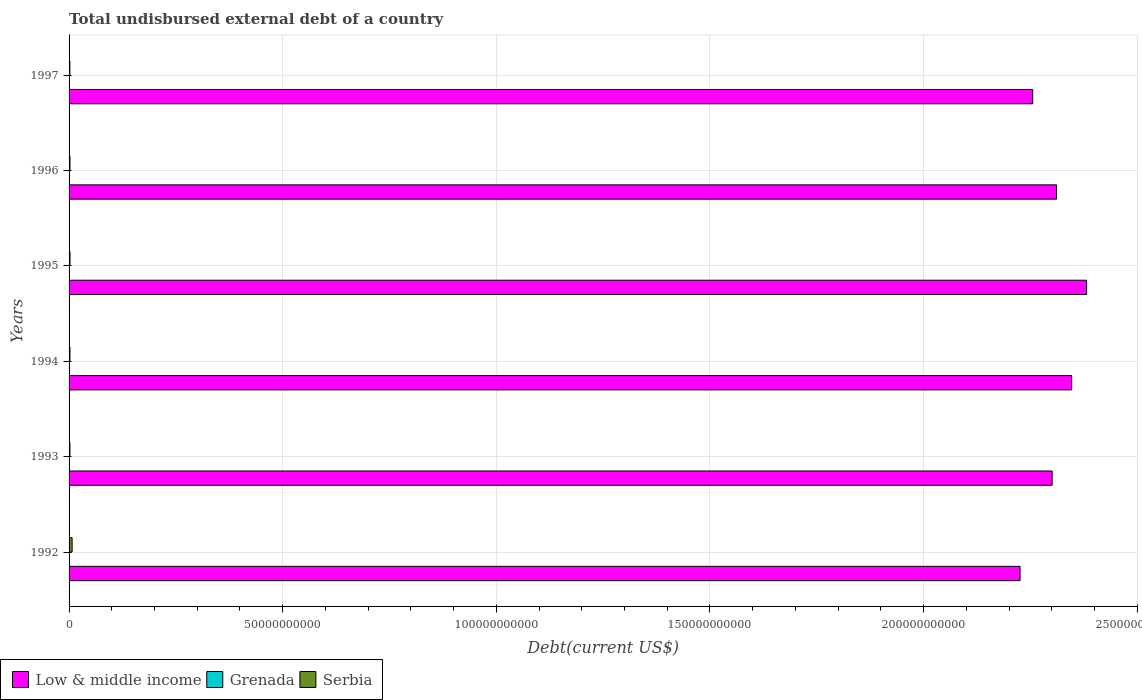Are the number of bars per tick equal to the number of legend labels?
Ensure brevity in your answer.  Yes. Are the number of bars on each tick of the Y-axis equal?
Your answer should be very brief. Yes. What is the label of the 2nd group of bars from the top?
Keep it short and to the point. 1996. What is the total undisbursed external debt in Serbia in 1993?
Ensure brevity in your answer.  2.00e+08. Across all years, what is the maximum total undisbursed external debt in Serbia?
Provide a succinct answer. 7.14e+08. Across all years, what is the minimum total undisbursed external debt in Low & middle income?
Give a very brief answer. 2.23e+11. In which year was the total undisbursed external debt in Serbia maximum?
Offer a terse response. 1992. What is the total total undisbursed external debt in Low & middle income in the graph?
Give a very brief answer. 1.38e+12. What is the difference between the total undisbursed external debt in Low & middle income in 1992 and that in 1996?
Offer a terse response. -8.54e+09. What is the difference between the total undisbursed external debt in Low & middle income in 1994 and the total undisbursed external debt in Serbia in 1995?
Your answer should be very brief. 2.34e+11. What is the average total undisbursed external debt in Serbia per year?
Keep it short and to the point. 2.91e+08. In the year 1992, what is the difference between the total undisbursed external debt in Low & middle income and total undisbursed external debt in Serbia?
Your response must be concise. 2.22e+11. What is the ratio of the total undisbursed external debt in Serbia in 1992 to that in 1996?
Your answer should be compact. 3.37. Is the difference between the total undisbursed external debt in Low & middle income in 1994 and 1996 greater than the difference between the total undisbursed external debt in Serbia in 1994 and 1996?
Offer a terse response. Yes. What is the difference between the highest and the second highest total undisbursed external debt in Low & middle income?
Your response must be concise. 3.49e+09. What is the difference between the highest and the lowest total undisbursed external debt in Grenada?
Keep it short and to the point. 1.32e+07. Is the sum of the total undisbursed external debt in Low & middle income in 1993 and 1995 greater than the maximum total undisbursed external debt in Serbia across all years?
Make the answer very short. Yes. What does the 2nd bar from the top in 1997 represents?
Make the answer very short. Grenada. How many bars are there?
Ensure brevity in your answer.  18. How many years are there in the graph?
Provide a succinct answer. 6. What is the difference between two consecutive major ticks on the X-axis?
Your response must be concise. 5.00e+1. Does the graph contain grids?
Provide a succinct answer. Yes. Where does the legend appear in the graph?
Provide a short and direct response. Bottom left. How many legend labels are there?
Your answer should be compact. 3. How are the legend labels stacked?
Your answer should be very brief. Horizontal. What is the title of the graph?
Provide a short and direct response. Total undisbursed external debt of a country. Does "Moldova" appear as one of the legend labels in the graph?
Provide a short and direct response. No. What is the label or title of the X-axis?
Provide a short and direct response. Debt(current US$). What is the Debt(current US$) of Low & middle income in 1992?
Provide a succinct answer. 2.23e+11. What is the Debt(current US$) in Grenada in 1992?
Your answer should be compact. 2.28e+07. What is the Debt(current US$) in Serbia in 1992?
Give a very brief answer. 7.14e+08. What is the Debt(current US$) of Low & middle income in 1993?
Offer a terse response. 2.30e+11. What is the Debt(current US$) of Grenada in 1993?
Make the answer very short. 1.79e+07. What is the Debt(current US$) of Serbia in 1993?
Offer a very short reply. 2.00e+08. What is the Debt(current US$) of Low & middle income in 1994?
Make the answer very short. 2.35e+11. What is the Debt(current US$) in Grenada in 1994?
Offer a very short reply. 1.91e+07. What is the Debt(current US$) in Serbia in 1994?
Give a very brief answer. 2.08e+08. What is the Debt(current US$) of Low & middle income in 1995?
Your response must be concise. 2.38e+11. What is the Debt(current US$) of Grenada in 1995?
Give a very brief answer. 3.11e+07. What is the Debt(current US$) of Serbia in 1995?
Ensure brevity in your answer.  2.22e+08. What is the Debt(current US$) in Low & middle income in 1996?
Offer a very short reply. 2.31e+11. What is the Debt(current US$) in Grenada in 1996?
Your answer should be compact. 2.90e+07. What is the Debt(current US$) in Serbia in 1996?
Keep it short and to the point. 2.12e+08. What is the Debt(current US$) in Low & middle income in 1997?
Ensure brevity in your answer.  2.26e+11. What is the Debt(current US$) in Grenada in 1997?
Provide a short and direct response. 2.65e+07. What is the Debt(current US$) in Serbia in 1997?
Offer a terse response. 1.87e+08. Across all years, what is the maximum Debt(current US$) in Low & middle income?
Your answer should be compact. 2.38e+11. Across all years, what is the maximum Debt(current US$) of Grenada?
Your answer should be compact. 3.11e+07. Across all years, what is the maximum Debt(current US$) of Serbia?
Provide a short and direct response. 7.14e+08. Across all years, what is the minimum Debt(current US$) of Low & middle income?
Keep it short and to the point. 2.23e+11. Across all years, what is the minimum Debt(current US$) of Grenada?
Provide a short and direct response. 1.79e+07. Across all years, what is the minimum Debt(current US$) in Serbia?
Provide a short and direct response. 1.87e+08. What is the total Debt(current US$) of Low & middle income in the graph?
Provide a succinct answer. 1.38e+12. What is the total Debt(current US$) in Grenada in the graph?
Provide a short and direct response. 1.46e+08. What is the total Debt(current US$) in Serbia in the graph?
Your response must be concise. 1.74e+09. What is the difference between the Debt(current US$) of Low & middle income in 1992 and that in 1993?
Ensure brevity in your answer.  -7.50e+09. What is the difference between the Debt(current US$) in Grenada in 1992 and that in 1993?
Make the answer very short. 4.84e+06. What is the difference between the Debt(current US$) of Serbia in 1992 and that in 1993?
Your response must be concise. 5.14e+08. What is the difference between the Debt(current US$) of Low & middle income in 1992 and that in 1994?
Your response must be concise. -1.21e+1. What is the difference between the Debt(current US$) of Grenada in 1992 and that in 1994?
Ensure brevity in your answer.  3.63e+06. What is the difference between the Debt(current US$) in Serbia in 1992 and that in 1994?
Provide a succinct answer. 5.06e+08. What is the difference between the Debt(current US$) in Low & middle income in 1992 and that in 1995?
Provide a succinct answer. -1.56e+1. What is the difference between the Debt(current US$) of Grenada in 1992 and that in 1995?
Your answer should be very brief. -8.35e+06. What is the difference between the Debt(current US$) in Serbia in 1992 and that in 1995?
Offer a terse response. 4.91e+08. What is the difference between the Debt(current US$) of Low & middle income in 1992 and that in 1996?
Give a very brief answer. -8.54e+09. What is the difference between the Debt(current US$) in Grenada in 1992 and that in 1996?
Your response must be concise. -6.27e+06. What is the difference between the Debt(current US$) in Serbia in 1992 and that in 1996?
Provide a succinct answer. 5.02e+08. What is the difference between the Debt(current US$) of Low & middle income in 1992 and that in 1997?
Your response must be concise. -2.96e+09. What is the difference between the Debt(current US$) of Grenada in 1992 and that in 1997?
Offer a very short reply. -3.69e+06. What is the difference between the Debt(current US$) in Serbia in 1992 and that in 1997?
Your answer should be compact. 5.27e+08. What is the difference between the Debt(current US$) of Low & middle income in 1993 and that in 1994?
Keep it short and to the point. -4.58e+09. What is the difference between the Debt(current US$) in Grenada in 1993 and that in 1994?
Provide a short and direct response. -1.21e+06. What is the difference between the Debt(current US$) of Serbia in 1993 and that in 1994?
Ensure brevity in your answer.  -7.94e+06. What is the difference between the Debt(current US$) of Low & middle income in 1993 and that in 1995?
Ensure brevity in your answer.  -8.07e+09. What is the difference between the Debt(current US$) in Grenada in 1993 and that in 1995?
Make the answer very short. -1.32e+07. What is the difference between the Debt(current US$) of Serbia in 1993 and that in 1995?
Provide a succinct answer. -2.22e+07. What is the difference between the Debt(current US$) in Low & middle income in 1993 and that in 1996?
Ensure brevity in your answer.  -1.03e+09. What is the difference between the Debt(current US$) of Grenada in 1993 and that in 1996?
Ensure brevity in your answer.  -1.11e+07. What is the difference between the Debt(current US$) in Serbia in 1993 and that in 1996?
Offer a terse response. -1.18e+07. What is the difference between the Debt(current US$) of Low & middle income in 1993 and that in 1997?
Your answer should be very brief. 4.54e+09. What is the difference between the Debt(current US$) in Grenada in 1993 and that in 1997?
Keep it short and to the point. -8.53e+06. What is the difference between the Debt(current US$) of Serbia in 1993 and that in 1997?
Offer a terse response. 1.34e+07. What is the difference between the Debt(current US$) in Low & middle income in 1994 and that in 1995?
Your response must be concise. -3.49e+09. What is the difference between the Debt(current US$) in Grenada in 1994 and that in 1995?
Give a very brief answer. -1.20e+07. What is the difference between the Debt(current US$) in Serbia in 1994 and that in 1995?
Provide a succinct answer. -1.42e+07. What is the difference between the Debt(current US$) of Low & middle income in 1994 and that in 1996?
Your answer should be compact. 3.55e+09. What is the difference between the Debt(current US$) in Grenada in 1994 and that in 1996?
Provide a short and direct response. -9.90e+06. What is the difference between the Debt(current US$) in Serbia in 1994 and that in 1996?
Offer a terse response. -3.88e+06. What is the difference between the Debt(current US$) of Low & middle income in 1994 and that in 1997?
Provide a short and direct response. 9.12e+09. What is the difference between the Debt(current US$) of Grenada in 1994 and that in 1997?
Your answer should be very brief. -7.32e+06. What is the difference between the Debt(current US$) in Serbia in 1994 and that in 1997?
Provide a succinct answer. 2.13e+07. What is the difference between the Debt(current US$) in Low & middle income in 1995 and that in 1996?
Offer a very short reply. 7.04e+09. What is the difference between the Debt(current US$) of Grenada in 1995 and that in 1996?
Provide a succinct answer. 2.07e+06. What is the difference between the Debt(current US$) in Serbia in 1995 and that in 1996?
Offer a terse response. 1.04e+07. What is the difference between the Debt(current US$) in Low & middle income in 1995 and that in 1997?
Provide a succinct answer. 1.26e+1. What is the difference between the Debt(current US$) in Grenada in 1995 and that in 1997?
Keep it short and to the point. 4.65e+06. What is the difference between the Debt(current US$) of Serbia in 1995 and that in 1997?
Offer a terse response. 3.55e+07. What is the difference between the Debt(current US$) in Low & middle income in 1996 and that in 1997?
Offer a terse response. 5.58e+09. What is the difference between the Debt(current US$) of Grenada in 1996 and that in 1997?
Your answer should be compact. 2.58e+06. What is the difference between the Debt(current US$) in Serbia in 1996 and that in 1997?
Your answer should be very brief. 2.52e+07. What is the difference between the Debt(current US$) of Low & middle income in 1992 and the Debt(current US$) of Grenada in 1993?
Give a very brief answer. 2.23e+11. What is the difference between the Debt(current US$) of Low & middle income in 1992 and the Debt(current US$) of Serbia in 1993?
Provide a short and direct response. 2.22e+11. What is the difference between the Debt(current US$) in Grenada in 1992 and the Debt(current US$) in Serbia in 1993?
Offer a very short reply. -1.77e+08. What is the difference between the Debt(current US$) of Low & middle income in 1992 and the Debt(current US$) of Grenada in 1994?
Your answer should be compact. 2.23e+11. What is the difference between the Debt(current US$) in Low & middle income in 1992 and the Debt(current US$) in Serbia in 1994?
Your answer should be very brief. 2.22e+11. What is the difference between the Debt(current US$) in Grenada in 1992 and the Debt(current US$) in Serbia in 1994?
Your response must be concise. -1.85e+08. What is the difference between the Debt(current US$) of Low & middle income in 1992 and the Debt(current US$) of Grenada in 1995?
Provide a succinct answer. 2.23e+11. What is the difference between the Debt(current US$) of Low & middle income in 1992 and the Debt(current US$) of Serbia in 1995?
Your answer should be very brief. 2.22e+11. What is the difference between the Debt(current US$) of Grenada in 1992 and the Debt(current US$) of Serbia in 1995?
Provide a succinct answer. -2.00e+08. What is the difference between the Debt(current US$) in Low & middle income in 1992 and the Debt(current US$) in Grenada in 1996?
Keep it short and to the point. 2.23e+11. What is the difference between the Debt(current US$) of Low & middle income in 1992 and the Debt(current US$) of Serbia in 1996?
Keep it short and to the point. 2.22e+11. What is the difference between the Debt(current US$) of Grenada in 1992 and the Debt(current US$) of Serbia in 1996?
Your response must be concise. -1.89e+08. What is the difference between the Debt(current US$) of Low & middle income in 1992 and the Debt(current US$) of Grenada in 1997?
Offer a very short reply. 2.23e+11. What is the difference between the Debt(current US$) of Low & middle income in 1992 and the Debt(current US$) of Serbia in 1997?
Your response must be concise. 2.22e+11. What is the difference between the Debt(current US$) of Grenada in 1992 and the Debt(current US$) of Serbia in 1997?
Offer a very short reply. -1.64e+08. What is the difference between the Debt(current US$) of Low & middle income in 1993 and the Debt(current US$) of Grenada in 1994?
Provide a short and direct response. 2.30e+11. What is the difference between the Debt(current US$) of Low & middle income in 1993 and the Debt(current US$) of Serbia in 1994?
Your answer should be very brief. 2.30e+11. What is the difference between the Debt(current US$) in Grenada in 1993 and the Debt(current US$) in Serbia in 1994?
Give a very brief answer. -1.90e+08. What is the difference between the Debt(current US$) in Low & middle income in 1993 and the Debt(current US$) in Grenada in 1995?
Provide a succinct answer. 2.30e+11. What is the difference between the Debt(current US$) in Low & middle income in 1993 and the Debt(current US$) in Serbia in 1995?
Ensure brevity in your answer.  2.30e+11. What is the difference between the Debt(current US$) of Grenada in 1993 and the Debt(current US$) of Serbia in 1995?
Offer a terse response. -2.04e+08. What is the difference between the Debt(current US$) of Low & middle income in 1993 and the Debt(current US$) of Grenada in 1996?
Give a very brief answer. 2.30e+11. What is the difference between the Debt(current US$) in Low & middle income in 1993 and the Debt(current US$) in Serbia in 1996?
Offer a very short reply. 2.30e+11. What is the difference between the Debt(current US$) of Grenada in 1993 and the Debt(current US$) of Serbia in 1996?
Offer a very short reply. -1.94e+08. What is the difference between the Debt(current US$) of Low & middle income in 1993 and the Debt(current US$) of Grenada in 1997?
Keep it short and to the point. 2.30e+11. What is the difference between the Debt(current US$) of Low & middle income in 1993 and the Debt(current US$) of Serbia in 1997?
Provide a succinct answer. 2.30e+11. What is the difference between the Debt(current US$) of Grenada in 1993 and the Debt(current US$) of Serbia in 1997?
Your response must be concise. -1.69e+08. What is the difference between the Debt(current US$) in Low & middle income in 1994 and the Debt(current US$) in Grenada in 1995?
Provide a succinct answer. 2.35e+11. What is the difference between the Debt(current US$) in Low & middle income in 1994 and the Debt(current US$) in Serbia in 1995?
Offer a terse response. 2.34e+11. What is the difference between the Debt(current US$) of Grenada in 1994 and the Debt(current US$) of Serbia in 1995?
Provide a succinct answer. -2.03e+08. What is the difference between the Debt(current US$) in Low & middle income in 1994 and the Debt(current US$) in Grenada in 1996?
Your answer should be compact. 2.35e+11. What is the difference between the Debt(current US$) in Low & middle income in 1994 and the Debt(current US$) in Serbia in 1996?
Keep it short and to the point. 2.34e+11. What is the difference between the Debt(current US$) of Grenada in 1994 and the Debt(current US$) of Serbia in 1996?
Ensure brevity in your answer.  -1.93e+08. What is the difference between the Debt(current US$) in Low & middle income in 1994 and the Debt(current US$) in Grenada in 1997?
Make the answer very short. 2.35e+11. What is the difference between the Debt(current US$) of Low & middle income in 1994 and the Debt(current US$) of Serbia in 1997?
Provide a short and direct response. 2.34e+11. What is the difference between the Debt(current US$) in Grenada in 1994 and the Debt(current US$) in Serbia in 1997?
Provide a short and direct response. -1.68e+08. What is the difference between the Debt(current US$) in Low & middle income in 1995 and the Debt(current US$) in Grenada in 1996?
Provide a short and direct response. 2.38e+11. What is the difference between the Debt(current US$) in Low & middle income in 1995 and the Debt(current US$) in Serbia in 1996?
Give a very brief answer. 2.38e+11. What is the difference between the Debt(current US$) in Grenada in 1995 and the Debt(current US$) in Serbia in 1996?
Make the answer very short. -1.81e+08. What is the difference between the Debt(current US$) of Low & middle income in 1995 and the Debt(current US$) of Grenada in 1997?
Make the answer very short. 2.38e+11. What is the difference between the Debt(current US$) of Low & middle income in 1995 and the Debt(current US$) of Serbia in 1997?
Your answer should be very brief. 2.38e+11. What is the difference between the Debt(current US$) in Grenada in 1995 and the Debt(current US$) in Serbia in 1997?
Keep it short and to the point. -1.56e+08. What is the difference between the Debt(current US$) in Low & middle income in 1996 and the Debt(current US$) in Grenada in 1997?
Provide a succinct answer. 2.31e+11. What is the difference between the Debt(current US$) of Low & middle income in 1996 and the Debt(current US$) of Serbia in 1997?
Your response must be concise. 2.31e+11. What is the difference between the Debt(current US$) of Grenada in 1996 and the Debt(current US$) of Serbia in 1997?
Provide a short and direct response. -1.58e+08. What is the average Debt(current US$) in Low & middle income per year?
Your answer should be very brief. 2.30e+11. What is the average Debt(current US$) of Grenada per year?
Offer a terse response. 2.44e+07. What is the average Debt(current US$) of Serbia per year?
Provide a short and direct response. 2.91e+08. In the year 1992, what is the difference between the Debt(current US$) in Low & middle income and Debt(current US$) in Grenada?
Give a very brief answer. 2.23e+11. In the year 1992, what is the difference between the Debt(current US$) in Low & middle income and Debt(current US$) in Serbia?
Offer a very short reply. 2.22e+11. In the year 1992, what is the difference between the Debt(current US$) in Grenada and Debt(current US$) in Serbia?
Offer a very short reply. -6.91e+08. In the year 1993, what is the difference between the Debt(current US$) in Low & middle income and Debt(current US$) in Grenada?
Make the answer very short. 2.30e+11. In the year 1993, what is the difference between the Debt(current US$) of Low & middle income and Debt(current US$) of Serbia?
Make the answer very short. 2.30e+11. In the year 1993, what is the difference between the Debt(current US$) in Grenada and Debt(current US$) in Serbia?
Provide a short and direct response. -1.82e+08. In the year 1994, what is the difference between the Debt(current US$) of Low & middle income and Debt(current US$) of Grenada?
Your answer should be very brief. 2.35e+11. In the year 1994, what is the difference between the Debt(current US$) of Low & middle income and Debt(current US$) of Serbia?
Your response must be concise. 2.34e+11. In the year 1994, what is the difference between the Debt(current US$) of Grenada and Debt(current US$) of Serbia?
Make the answer very short. -1.89e+08. In the year 1995, what is the difference between the Debt(current US$) of Low & middle income and Debt(current US$) of Grenada?
Your response must be concise. 2.38e+11. In the year 1995, what is the difference between the Debt(current US$) of Low & middle income and Debt(current US$) of Serbia?
Your answer should be compact. 2.38e+11. In the year 1995, what is the difference between the Debt(current US$) in Grenada and Debt(current US$) in Serbia?
Your answer should be very brief. -1.91e+08. In the year 1996, what is the difference between the Debt(current US$) in Low & middle income and Debt(current US$) in Grenada?
Provide a short and direct response. 2.31e+11. In the year 1996, what is the difference between the Debt(current US$) in Low & middle income and Debt(current US$) in Serbia?
Provide a short and direct response. 2.31e+11. In the year 1996, what is the difference between the Debt(current US$) in Grenada and Debt(current US$) in Serbia?
Provide a succinct answer. -1.83e+08. In the year 1997, what is the difference between the Debt(current US$) in Low & middle income and Debt(current US$) in Grenada?
Your answer should be compact. 2.26e+11. In the year 1997, what is the difference between the Debt(current US$) of Low & middle income and Debt(current US$) of Serbia?
Give a very brief answer. 2.25e+11. In the year 1997, what is the difference between the Debt(current US$) of Grenada and Debt(current US$) of Serbia?
Offer a very short reply. -1.60e+08. What is the ratio of the Debt(current US$) of Low & middle income in 1992 to that in 1993?
Your answer should be very brief. 0.97. What is the ratio of the Debt(current US$) of Grenada in 1992 to that in 1993?
Offer a very short reply. 1.27. What is the ratio of the Debt(current US$) of Serbia in 1992 to that in 1993?
Provide a short and direct response. 3.57. What is the ratio of the Debt(current US$) in Low & middle income in 1992 to that in 1994?
Provide a succinct answer. 0.95. What is the ratio of the Debt(current US$) of Grenada in 1992 to that in 1994?
Offer a very short reply. 1.19. What is the ratio of the Debt(current US$) in Serbia in 1992 to that in 1994?
Provide a short and direct response. 3.43. What is the ratio of the Debt(current US$) in Low & middle income in 1992 to that in 1995?
Your answer should be very brief. 0.93. What is the ratio of the Debt(current US$) of Grenada in 1992 to that in 1995?
Give a very brief answer. 0.73. What is the ratio of the Debt(current US$) of Serbia in 1992 to that in 1995?
Give a very brief answer. 3.21. What is the ratio of the Debt(current US$) in Low & middle income in 1992 to that in 1996?
Offer a terse response. 0.96. What is the ratio of the Debt(current US$) of Grenada in 1992 to that in 1996?
Your answer should be very brief. 0.78. What is the ratio of the Debt(current US$) in Serbia in 1992 to that in 1996?
Ensure brevity in your answer.  3.37. What is the ratio of the Debt(current US$) of Low & middle income in 1992 to that in 1997?
Your answer should be compact. 0.99. What is the ratio of the Debt(current US$) in Grenada in 1992 to that in 1997?
Offer a very short reply. 0.86. What is the ratio of the Debt(current US$) in Serbia in 1992 to that in 1997?
Make the answer very short. 3.82. What is the ratio of the Debt(current US$) in Low & middle income in 1993 to that in 1994?
Offer a very short reply. 0.98. What is the ratio of the Debt(current US$) in Grenada in 1993 to that in 1994?
Make the answer very short. 0.94. What is the ratio of the Debt(current US$) of Serbia in 1993 to that in 1994?
Offer a terse response. 0.96. What is the ratio of the Debt(current US$) in Low & middle income in 1993 to that in 1995?
Offer a terse response. 0.97. What is the ratio of the Debt(current US$) in Grenada in 1993 to that in 1995?
Make the answer very short. 0.58. What is the ratio of the Debt(current US$) of Serbia in 1993 to that in 1995?
Your response must be concise. 0.9. What is the ratio of the Debt(current US$) in Grenada in 1993 to that in 1996?
Your answer should be compact. 0.62. What is the ratio of the Debt(current US$) of Serbia in 1993 to that in 1996?
Provide a short and direct response. 0.94. What is the ratio of the Debt(current US$) of Low & middle income in 1993 to that in 1997?
Provide a succinct answer. 1.02. What is the ratio of the Debt(current US$) of Grenada in 1993 to that in 1997?
Your answer should be compact. 0.68. What is the ratio of the Debt(current US$) in Serbia in 1993 to that in 1997?
Make the answer very short. 1.07. What is the ratio of the Debt(current US$) of Grenada in 1994 to that in 1995?
Your answer should be very brief. 0.62. What is the ratio of the Debt(current US$) in Serbia in 1994 to that in 1995?
Your response must be concise. 0.94. What is the ratio of the Debt(current US$) of Low & middle income in 1994 to that in 1996?
Ensure brevity in your answer.  1.02. What is the ratio of the Debt(current US$) in Grenada in 1994 to that in 1996?
Offer a terse response. 0.66. What is the ratio of the Debt(current US$) of Serbia in 1994 to that in 1996?
Your response must be concise. 0.98. What is the ratio of the Debt(current US$) in Low & middle income in 1994 to that in 1997?
Your answer should be compact. 1.04. What is the ratio of the Debt(current US$) in Grenada in 1994 to that in 1997?
Your answer should be compact. 0.72. What is the ratio of the Debt(current US$) of Serbia in 1994 to that in 1997?
Offer a terse response. 1.11. What is the ratio of the Debt(current US$) in Low & middle income in 1995 to that in 1996?
Give a very brief answer. 1.03. What is the ratio of the Debt(current US$) in Grenada in 1995 to that in 1996?
Offer a terse response. 1.07. What is the ratio of the Debt(current US$) of Serbia in 1995 to that in 1996?
Offer a very short reply. 1.05. What is the ratio of the Debt(current US$) of Low & middle income in 1995 to that in 1997?
Provide a succinct answer. 1.06. What is the ratio of the Debt(current US$) of Grenada in 1995 to that in 1997?
Offer a terse response. 1.18. What is the ratio of the Debt(current US$) in Serbia in 1995 to that in 1997?
Your answer should be compact. 1.19. What is the ratio of the Debt(current US$) in Low & middle income in 1996 to that in 1997?
Provide a short and direct response. 1.02. What is the ratio of the Debt(current US$) in Grenada in 1996 to that in 1997?
Your response must be concise. 1.1. What is the ratio of the Debt(current US$) of Serbia in 1996 to that in 1997?
Offer a very short reply. 1.13. What is the difference between the highest and the second highest Debt(current US$) of Low & middle income?
Provide a succinct answer. 3.49e+09. What is the difference between the highest and the second highest Debt(current US$) in Grenada?
Offer a very short reply. 2.07e+06. What is the difference between the highest and the second highest Debt(current US$) of Serbia?
Provide a short and direct response. 4.91e+08. What is the difference between the highest and the lowest Debt(current US$) of Low & middle income?
Offer a very short reply. 1.56e+1. What is the difference between the highest and the lowest Debt(current US$) of Grenada?
Your answer should be very brief. 1.32e+07. What is the difference between the highest and the lowest Debt(current US$) of Serbia?
Offer a very short reply. 5.27e+08. 